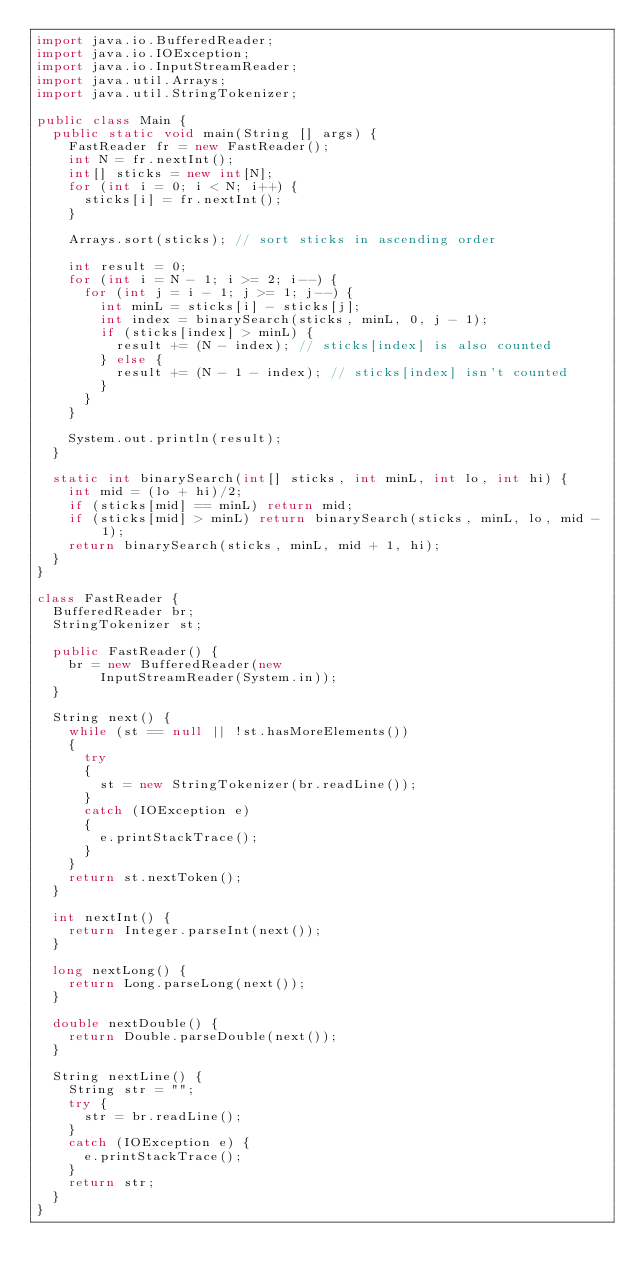<code> <loc_0><loc_0><loc_500><loc_500><_Java_>import java.io.BufferedReader;
import java.io.IOException;
import java.io.InputStreamReader;
import java.util.Arrays;
import java.util.StringTokenizer;

public class Main {
  public static void main(String [] args) {
    FastReader fr = new FastReader();
    int N = fr.nextInt();
    int[] sticks = new int[N];
    for (int i = 0; i < N; i++) {
      sticks[i] = fr.nextInt();
    }

    Arrays.sort(sticks); // sort sticks in ascending order

    int result = 0;
    for (int i = N - 1; i >= 2; i--) {
      for (int j = i - 1; j >= 1; j--) {
        int minL = sticks[i] - sticks[j];
        int index = binarySearch(sticks, minL, 0, j - 1);
        if (sticks[index] > minL) {
          result += (N - index); // sticks[index] is also counted
        } else {
          result += (N - 1 - index); // sticks[index] isn't counted
        }
      }
    }

    System.out.println(result);
  }

  static int binarySearch(int[] sticks, int minL, int lo, int hi) {
    int mid = (lo + hi)/2;
    if (sticks[mid] == minL) return mid;
    if (sticks[mid] > minL) return binarySearch(sticks, minL, lo, mid - 1);
    return binarySearch(sticks, minL, mid + 1, hi);
  }
}

class FastReader {
  BufferedReader br;
  StringTokenizer st;

  public FastReader() {
    br = new BufferedReader(new
        InputStreamReader(System.in));
  }

  String next() {
    while (st == null || !st.hasMoreElements())
    {
      try
      {
        st = new StringTokenizer(br.readLine());
      }
      catch (IOException e)
      {
        e.printStackTrace();
      }
    }
    return st.nextToken();
  }

  int nextInt() {
    return Integer.parseInt(next());
  }

  long nextLong() {
    return Long.parseLong(next());
  }

  double nextDouble() {
    return Double.parseDouble(next());
  }

  String nextLine() {
    String str = "";
    try {
      str = br.readLine();
    }
    catch (IOException e) {
      e.printStackTrace();
    }
    return str;
  }
}</code> 